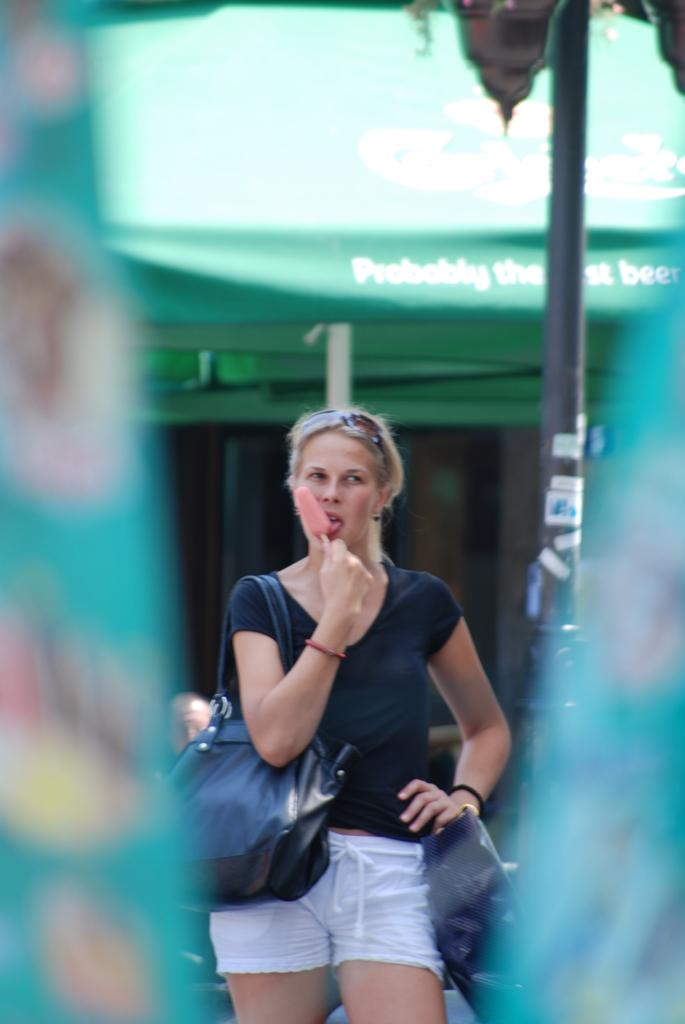What is the lady in the image wearing? The lady is wearing a black top and white shorts. What is the lady doing in the image? The lady is eating ice cream and carrying a bag. What can be seen in the background of the image? There is a green shed and a pole in the background of the image. Is the lady sitting on a throne in the image? There is no throne present in the image; the lady is not sitting on a throne. 